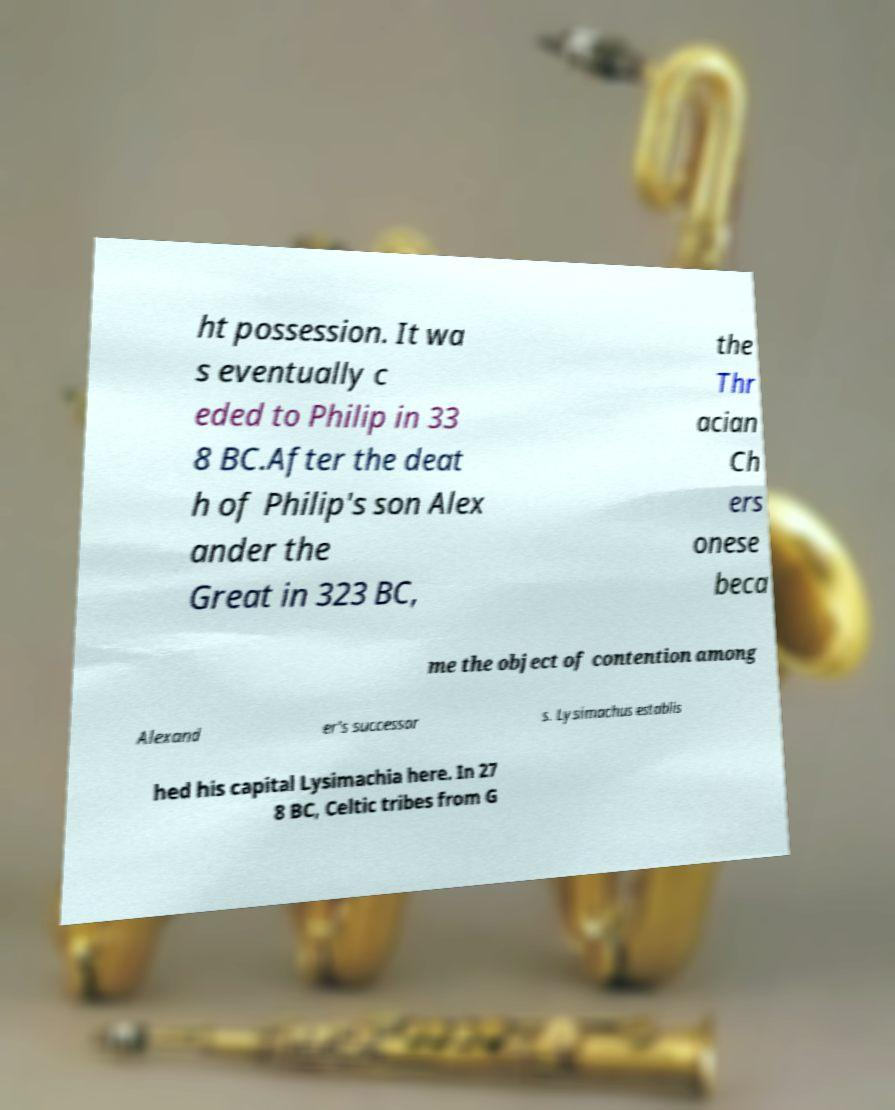For documentation purposes, I need the text within this image transcribed. Could you provide that? ht possession. It wa s eventually c eded to Philip in 33 8 BC.After the deat h of Philip's son Alex ander the Great in 323 BC, the Thr acian Ch ers onese beca me the object of contention among Alexand er's successor s. Lysimachus establis hed his capital Lysimachia here. In 27 8 BC, Celtic tribes from G 